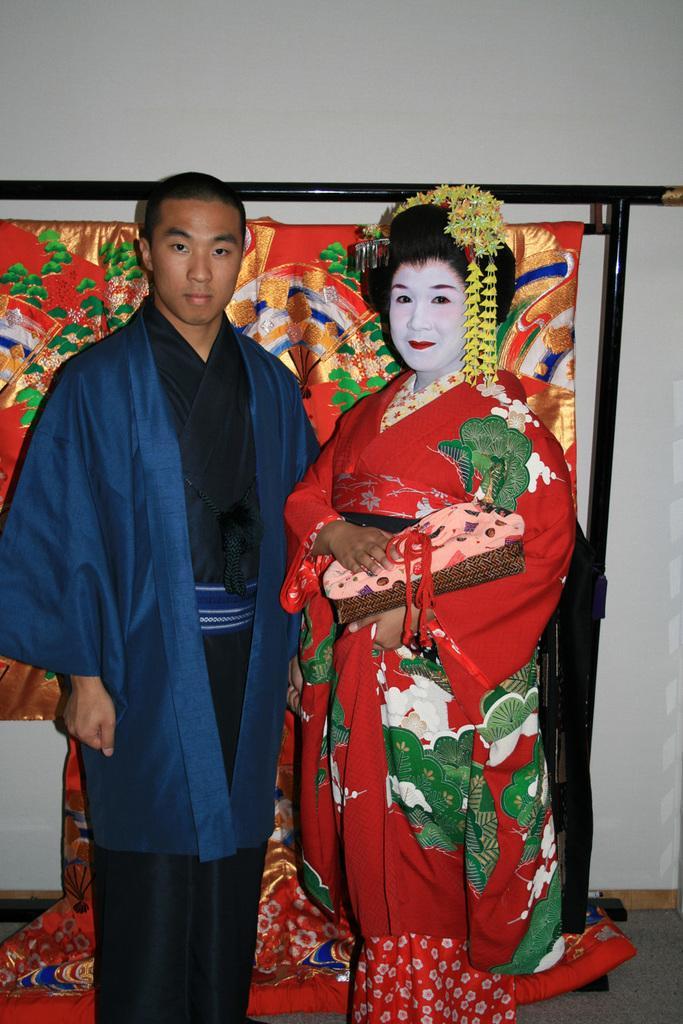In one or two sentences, can you explain what this image depicts? There are two people standing. They wore the Japanese traditional dresses. In the background, I think this is a cloth with a design, which is hanging on a hanger. I can see the wall. 